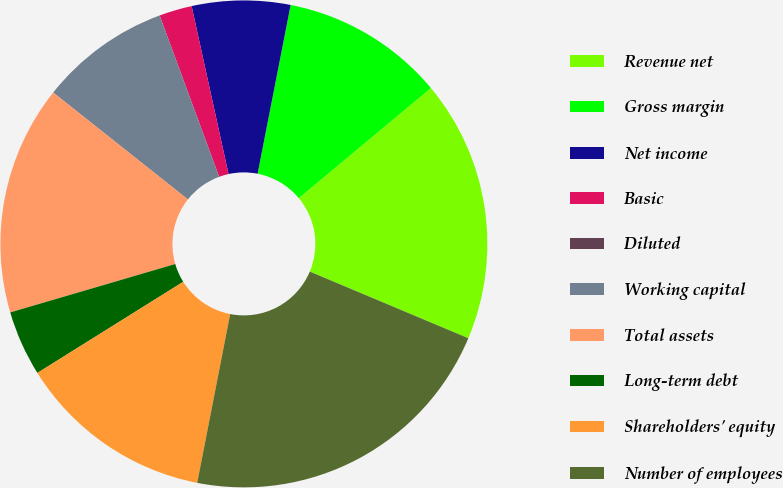<chart> <loc_0><loc_0><loc_500><loc_500><pie_chart><fcel>Revenue net<fcel>Gross margin<fcel>Net income<fcel>Basic<fcel>Diluted<fcel>Working capital<fcel>Total assets<fcel>Long-term debt<fcel>Shareholders' equity<fcel>Number of employees<nl><fcel>17.39%<fcel>10.87%<fcel>6.52%<fcel>2.18%<fcel>0.0%<fcel>8.7%<fcel>15.22%<fcel>4.35%<fcel>13.04%<fcel>21.74%<nl></chart> 